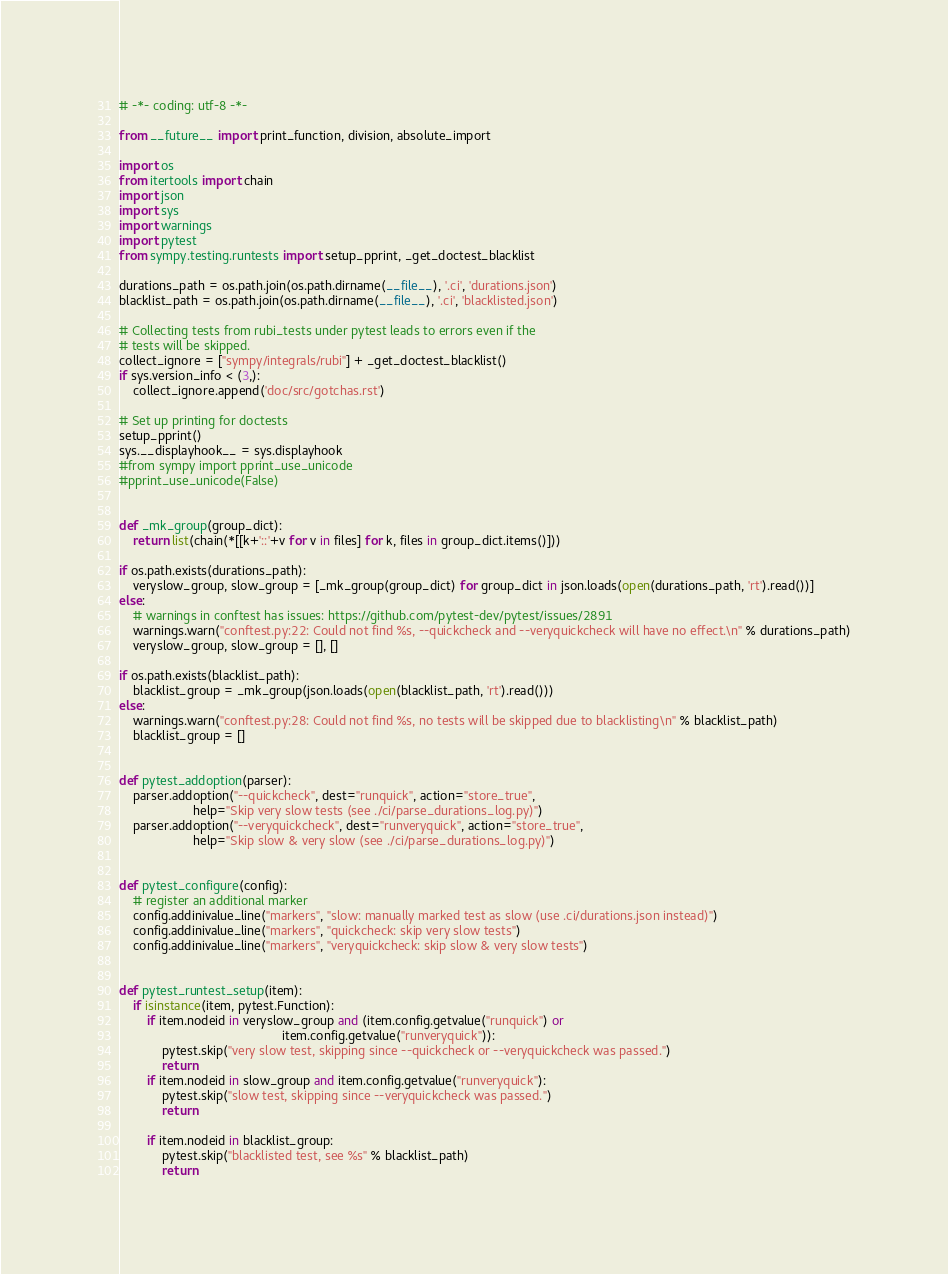Convert code to text. <code><loc_0><loc_0><loc_500><loc_500><_Python_># -*- coding: utf-8 -*-

from __future__ import print_function, division, absolute_import

import os
from itertools import chain
import json
import sys
import warnings
import pytest
from sympy.testing.runtests import setup_pprint, _get_doctest_blacklist

durations_path = os.path.join(os.path.dirname(__file__), '.ci', 'durations.json')
blacklist_path = os.path.join(os.path.dirname(__file__), '.ci', 'blacklisted.json')

# Collecting tests from rubi_tests under pytest leads to errors even if the
# tests will be skipped.
collect_ignore = ["sympy/integrals/rubi"] + _get_doctest_blacklist()
if sys.version_info < (3,):
    collect_ignore.append('doc/src/gotchas.rst')

# Set up printing for doctests
setup_pprint()
sys.__displayhook__ = sys.displayhook
#from sympy import pprint_use_unicode
#pprint_use_unicode(False)


def _mk_group(group_dict):
    return list(chain(*[[k+'::'+v for v in files] for k, files in group_dict.items()]))

if os.path.exists(durations_path):
    veryslow_group, slow_group = [_mk_group(group_dict) for group_dict in json.loads(open(durations_path, 'rt').read())]
else:
    # warnings in conftest has issues: https://github.com/pytest-dev/pytest/issues/2891
    warnings.warn("conftest.py:22: Could not find %s, --quickcheck and --veryquickcheck will have no effect.\n" % durations_path)
    veryslow_group, slow_group = [], []

if os.path.exists(blacklist_path):
    blacklist_group = _mk_group(json.loads(open(blacklist_path, 'rt').read()))
else:
    warnings.warn("conftest.py:28: Could not find %s, no tests will be skipped due to blacklisting\n" % blacklist_path)
    blacklist_group = []


def pytest_addoption(parser):
    parser.addoption("--quickcheck", dest="runquick", action="store_true",
                     help="Skip very slow tests (see ./ci/parse_durations_log.py)")
    parser.addoption("--veryquickcheck", dest="runveryquick", action="store_true",
                     help="Skip slow & very slow (see ./ci/parse_durations_log.py)")


def pytest_configure(config):
    # register an additional marker
    config.addinivalue_line("markers", "slow: manually marked test as slow (use .ci/durations.json instead)")
    config.addinivalue_line("markers", "quickcheck: skip very slow tests")
    config.addinivalue_line("markers", "veryquickcheck: skip slow & very slow tests")


def pytest_runtest_setup(item):
    if isinstance(item, pytest.Function):
        if item.nodeid in veryslow_group and (item.config.getvalue("runquick") or
                                              item.config.getvalue("runveryquick")):
            pytest.skip("very slow test, skipping since --quickcheck or --veryquickcheck was passed.")
            return
        if item.nodeid in slow_group and item.config.getvalue("runveryquick"):
            pytest.skip("slow test, skipping since --veryquickcheck was passed.")
            return

        if item.nodeid in blacklist_group:
            pytest.skip("blacklisted test, see %s" % blacklist_path)
            return
</code> 